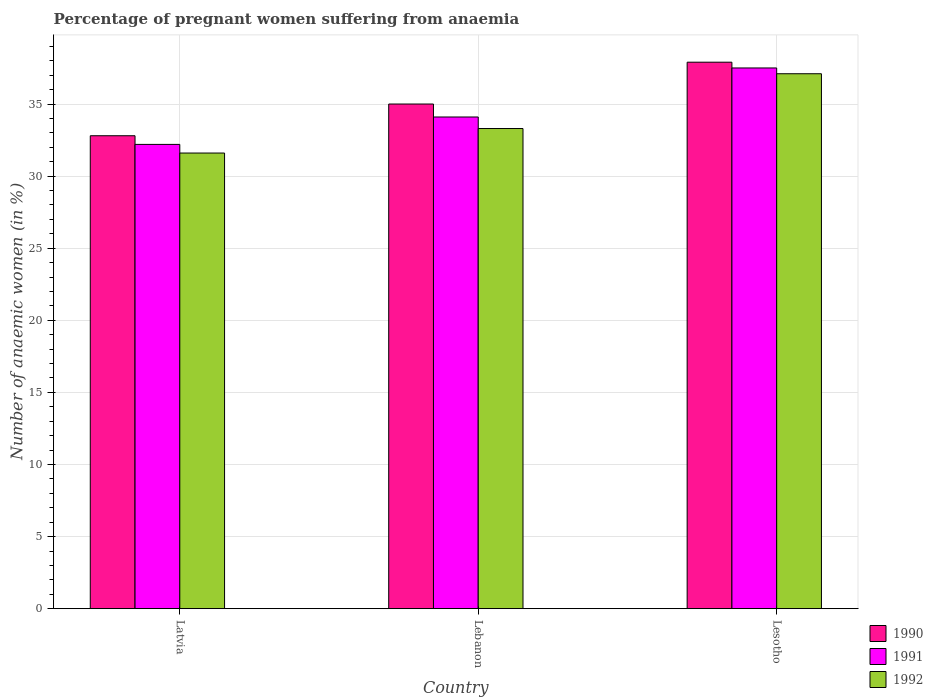Are the number of bars per tick equal to the number of legend labels?
Make the answer very short. Yes. Are the number of bars on each tick of the X-axis equal?
Your answer should be compact. Yes. How many bars are there on the 1st tick from the left?
Keep it short and to the point. 3. What is the label of the 2nd group of bars from the left?
Your response must be concise. Lebanon. What is the number of anaemic women in 1991 in Lebanon?
Keep it short and to the point. 34.1. Across all countries, what is the maximum number of anaemic women in 1990?
Your response must be concise. 37.9. Across all countries, what is the minimum number of anaemic women in 1990?
Your answer should be very brief. 32.8. In which country was the number of anaemic women in 1990 maximum?
Provide a succinct answer. Lesotho. In which country was the number of anaemic women in 1991 minimum?
Your answer should be compact. Latvia. What is the total number of anaemic women in 1990 in the graph?
Ensure brevity in your answer.  105.7. What is the difference between the number of anaemic women in 1992 in Lebanon and that in Lesotho?
Your answer should be compact. -3.8. What is the difference between the number of anaemic women in 1990 in Lebanon and the number of anaemic women in 1991 in Latvia?
Offer a terse response. 2.8. What is the average number of anaemic women in 1991 per country?
Offer a terse response. 34.6. What is the difference between the number of anaemic women of/in 1991 and number of anaemic women of/in 1992 in Latvia?
Keep it short and to the point. 0.6. In how many countries, is the number of anaemic women in 1990 greater than 34 %?
Provide a short and direct response. 2. What is the ratio of the number of anaemic women in 1992 in Latvia to that in Lebanon?
Offer a terse response. 0.95. Is the difference between the number of anaemic women in 1991 in Latvia and Lebanon greater than the difference between the number of anaemic women in 1992 in Latvia and Lebanon?
Keep it short and to the point. No. What is the difference between the highest and the second highest number of anaemic women in 1992?
Your answer should be very brief. -3.8. What is the difference between the highest and the lowest number of anaemic women in 1990?
Provide a succinct answer. 5.1. In how many countries, is the number of anaemic women in 1990 greater than the average number of anaemic women in 1990 taken over all countries?
Provide a succinct answer. 1. What does the 3rd bar from the left in Lebanon represents?
Offer a terse response. 1992. What does the 1st bar from the right in Lebanon represents?
Your answer should be compact. 1992. Is it the case that in every country, the sum of the number of anaemic women in 1991 and number of anaemic women in 1990 is greater than the number of anaemic women in 1992?
Your answer should be compact. Yes. What is the difference between two consecutive major ticks on the Y-axis?
Your answer should be compact. 5. Are the values on the major ticks of Y-axis written in scientific E-notation?
Your answer should be very brief. No. Does the graph contain any zero values?
Give a very brief answer. No. How many legend labels are there?
Ensure brevity in your answer.  3. What is the title of the graph?
Your answer should be compact. Percentage of pregnant women suffering from anaemia. Does "2008" appear as one of the legend labels in the graph?
Keep it short and to the point. No. What is the label or title of the X-axis?
Keep it short and to the point. Country. What is the label or title of the Y-axis?
Make the answer very short. Number of anaemic women (in %). What is the Number of anaemic women (in %) of 1990 in Latvia?
Offer a very short reply. 32.8. What is the Number of anaemic women (in %) of 1991 in Latvia?
Your answer should be very brief. 32.2. What is the Number of anaemic women (in %) of 1992 in Latvia?
Make the answer very short. 31.6. What is the Number of anaemic women (in %) in 1991 in Lebanon?
Provide a short and direct response. 34.1. What is the Number of anaemic women (in %) of 1992 in Lebanon?
Provide a short and direct response. 33.3. What is the Number of anaemic women (in %) of 1990 in Lesotho?
Provide a short and direct response. 37.9. What is the Number of anaemic women (in %) of 1991 in Lesotho?
Provide a short and direct response. 37.5. What is the Number of anaemic women (in %) in 1992 in Lesotho?
Provide a short and direct response. 37.1. Across all countries, what is the maximum Number of anaemic women (in %) of 1990?
Your response must be concise. 37.9. Across all countries, what is the maximum Number of anaemic women (in %) of 1991?
Ensure brevity in your answer.  37.5. Across all countries, what is the maximum Number of anaemic women (in %) in 1992?
Offer a very short reply. 37.1. Across all countries, what is the minimum Number of anaemic women (in %) in 1990?
Ensure brevity in your answer.  32.8. Across all countries, what is the minimum Number of anaemic women (in %) of 1991?
Provide a short and direct response. 32.2. Across all countries, what is the minimum Number of anaemic women (in %) of 1992?
Your response must be concise. 31.6. What is the total Number of anaemic women (in %) in 1990 in the graph?
Provide a short and direct response. 105.7. What is the total Number of anaemic women (in %) in 1991 in the graph?
Provide a succinct answer. 103.8. What is the total Number of anaemic women (in %) of 1992 in the graph?
Your answer should be very brief. 102. What is the difference between the Number of anaemic women (in %) of 1990 in Latvia and that in Lebanon?
Provide a short and direct response. -2.2. What is the difference between the Number of anaemic women (in %) of 1990 in Latvia and that in Lesotho?
Provide a short and direct response. -5.1. What is the difference between the Number of anaemic women (in %) in 1992 in Latvia and that in Lesotho?
Offer a terse response. -5.5. What is the difference between the Number of anaemic women (in %) in 1992 in Lebanon and that in Lesotho?
Provide a succinct answer. -3.8. What is the difference between the Number of anaemic women (in %) in 1990 in Latvia and the Number of anaemic women (in %) in 1992 in Lebanon?
Provide a short and direct response. -0.5. What is the difference between the Number of anaemic women (in %) in 1990 in Latvia and the Number of anaemic women (in %) in 1991 in Lesotho?
Ensure brevity in your answer.  -4.7. What is the difference between the Number of anaemic women (in %) of 1991 in Latvia and the Number of anaemic women (in %) of 1992 in Lesotho?
Your response must be concise. -4.9. What is the difference between the Number of anaemic women (in %) of 1990 in Lebanon and the Number of anaemic women (in %) of 1992 in Lesotho?
Offer a terse response. -2.1. What is the average Number of anaemic women (in %) in 1990 per country?
Offer a very short reply. 35.23. What is the average Number of anaemic women (in %) of 1991 per country?
Keep it short and to the point. 34.6. What is the difference between the Number of anaemic women (in %) in 1990 and Number of anaemic women (in %) in 1991 in Latvia?
Give a very brief answer. 0.6. What is the difference between the Number of anaemic women (in %) in 1990 and Number of anaemic women (in %) in 1992 in Latvia?
Make the answer very short. 1.2. What is the difference between the Number of anaemic women (in %) in 1990 and Number of anaemic women (in %) in 1991 in Lebanon?
Your answer should be very brief. 0.9. What is the difference between the Number of anaemic women (in %) of 1990 and Number of anaemic women (in %) of 1992 in Lebanon?
Offer a very short reply. 1.7. What is the difference between the Number of anaemic women (in %) of 1991 and Number of anaemic women (in %) of 1992 in Lebanon?
Your answer should be compact. 0.8. What is the difference between the Number of anaemic women (in %) in 1990 and Number of anaemic women (in %) in 1991 in Lesotho?
Offer a terse response. 0.4. What is the ratio of the Number of anaemic women (in %) in 1990 in Latvia to that in Lebanon?
Your response must be concise. 0.94. What is the ratio of the Number of anaemic women (in %) of 1991 in Latvia to that in Lebanon?
Make the answer very short. 0.94. What is the ratio of the Number of anaemic women (in %) of 1992 in Latvia to that in Lebanon?
Your answer should be compact. 0.95. What is the ratio of the Number of anaemic women (in %) of 1990 in Latvia to that in Lesotho?
Your response must be concise. 0.87. What is the ratio of the Number of anaemic women (in %) in 1991 in Latvia to that in Lesotho?
Offer a very short reply. 0.86. What is the ratio of the Number of anaemic women (in %) of 1992 in Latvia to that in Lesotho?
Make the answer very short. 0.85. What is the ratio of the Number of anaemic women (in %) in 1990 in Lebanon to that in Lesotho?
Provide a succinct answer. 0.92. What is the ratio of the Number of anaemic women (in %) in 1991 in Lebanon to that in Lesotho?
Give a very brief answer. 0.91. What is the ratio of the Number of anaemic women (in %) of 1992 in Lebanon to that in Lesotho?
Your answer should be compact. 0.9. What is the difference between the highest and the second highest Number of anaemic women (in %) in 1992?
Offer a very short reply. 3.8. What is the difference between the highest and the lowest Number of anaemic women (in %) in 1990?
Ensure brevity in your answer.  5.1. 